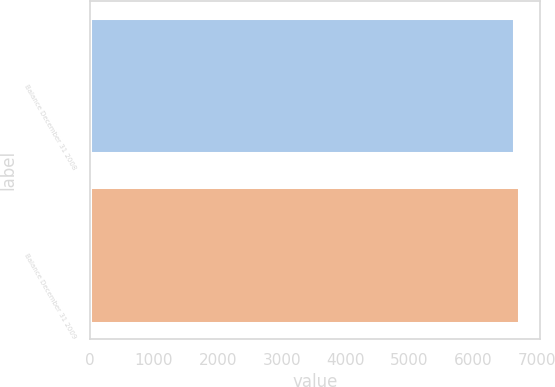Convert chart to OTSL. <chart><loc_0><loc_0><loc_500><loc_500><bar_chart><fcel>Balance December 31 2008<fcel>Balance December 31 2009<nl><fcel>6642<fcel>6713<nl></chart> 